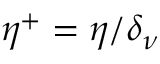<formula> <loc_0><loc_0><loc_500><loc_500>\eta ^ { + } = \eta / \delta _ { \nu }</formula> 